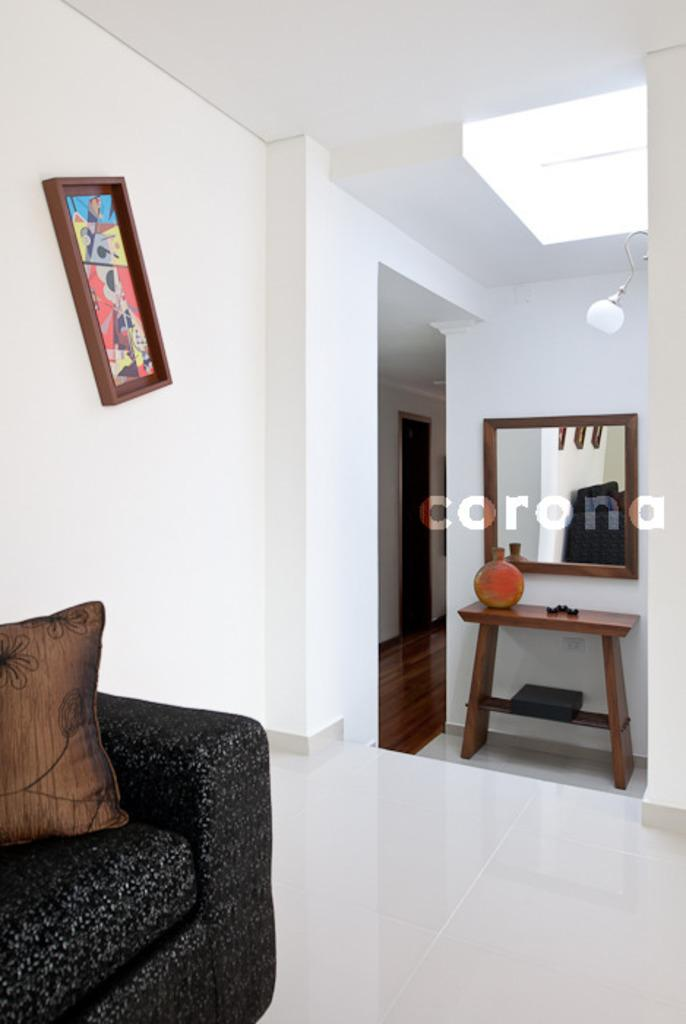What type of view is shown in the image? The image is an inside view. Where is the couch located in the room? The couch is in the left corner of the room. What is hanging on the wall beside the couch? There is a frame attached to the wall beside the couch. What is on the right side of the room? There is a mirror on the right side of the room. What is located below the mirror? There is a table below the mirror. What type of protest is happening outside the window in the image? There is no window or protest visible in the image; it is an inside view of a room. 